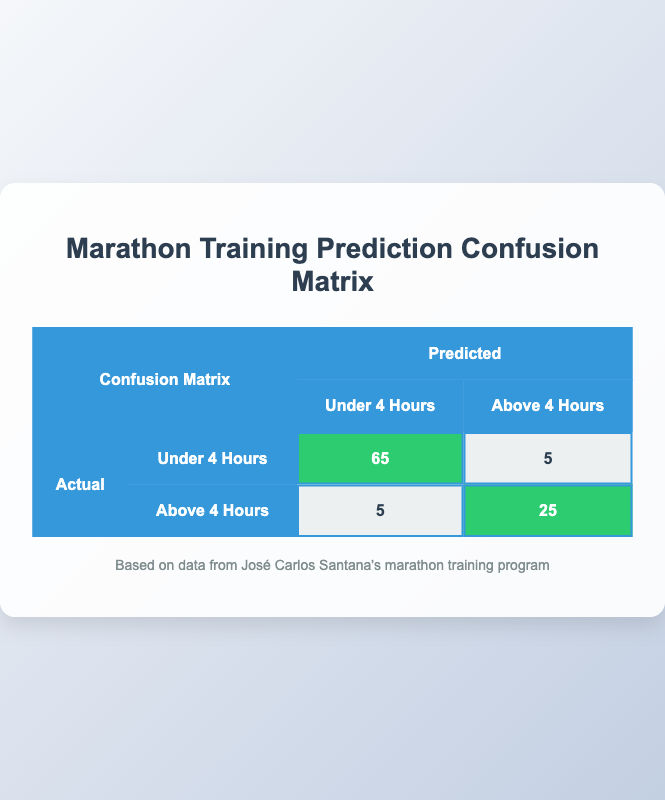What is the number of true positives for the prediction of finishing under 4 hours? The table shows that the true positive count for finishing under 4 hours is highlighted in the cell corresponding to "Under 4 Hours" for both actual and predicted, which is 65.
Answer: 65 How many athletes were predicted to finish above 4 hours? To find the number of athletes predicted to finish above 4 hours, we look at the predicted column for "Above 4 Hours" which includes both the true negatives and false negatives. It shows that there are 5 (false negatives) + 25 (true negatives) = 30 athletes predicted to finish above 4 hours.
Answer: 30 What is the false positive rate for the prediction of finishing under 4 hours? The false positive rate is calculated using the formula: false positives / (false positives + true negatives). Here, there are 5 false positives and 25 true negatives, so the false positive rate is 5 / (5 + 25) = 5 / 30 = 1/6 ≈ 0.167 or 16.7%.
Answer: Approximately 16.7% Is the number of true negatives equal to the false negatives? According to the table, the true negatives count is 25 while the false negatives count is 5. Since 25 does not equal 5, the statement is false.
Answer: No What is the total number of athletes who finished in under 4 hours? To find the total number of athletes finishing under 4 hours, we look at the actual counts. The actual total finishing under 4 hours is given directly as 70.
Answer: 70 What is the total number of athletes whose actual finish time was above 4 hours? To find this, we refer to the actual counts, where it states 30 athletes finished above 4 hours.
Answer: 30 How many predicted false negatives are there? The table shows that the false negatives are represented as 5 in the "Above 4 Hours" row, indicating there were 5 athletes who were predicted to finish under 4 hours but actually finished above 4 hours.
Answer: 5 What is the overall prediction accuracy for the marathon training program? The accuracy is calculated as (true positives + true negatives) / total predictions. Here, the sum of true positives (65) and true negatives (25) is 90. The total number of predictions (total athletes) is 100 (70 + 30). Therefore, the accuracy is 90 / 100 = 0.9 or 90%.
Answer: 90% What is the difference between true positives and false positives? The difference is calculated by subtracting false positives from true positives. The true positives are 65 and false positives are 5. Thus, 65 - 5 = 60.
Answer: 60 